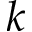Convert formula to latex. <formula><loc_0><loc_0><loc_500><loc_500>k</formula> 